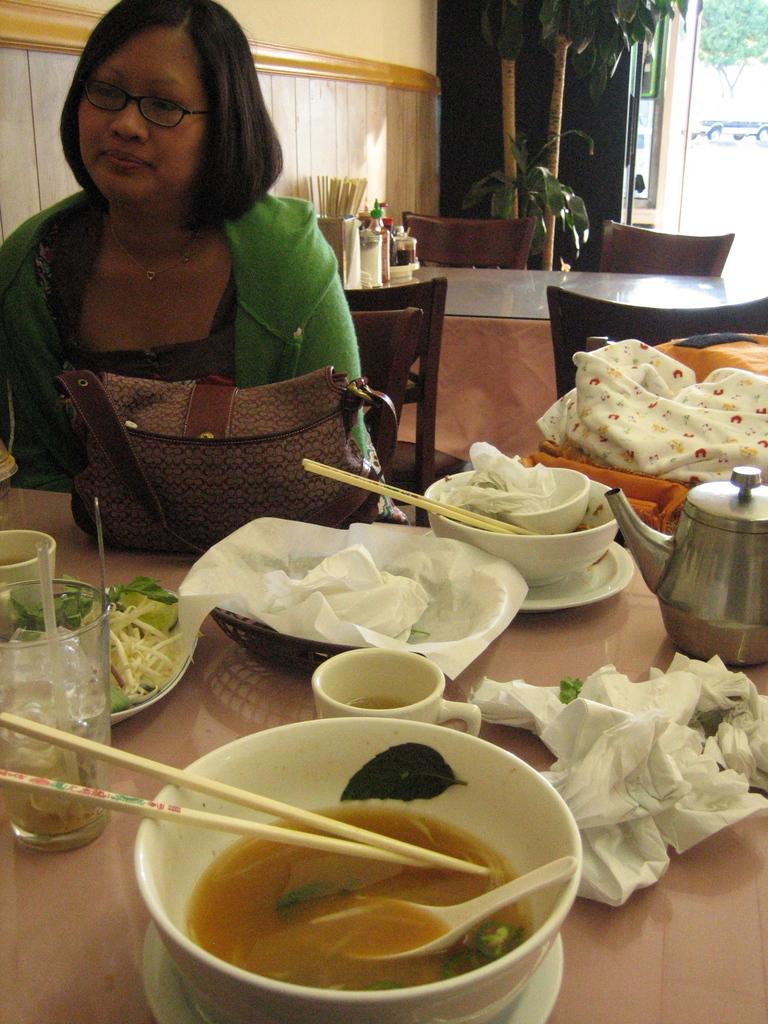What is the person in the image doing? The person is sitting on a chair in the image. Where is the person located in relation to the table? The person is around a table in the image. What can be found on the table in the image? There are food items on the table in the image. What is visible in the background of the image? There is a wall in the background of the image. How many scarecrows are present in the image? There are no scarecrows present in the image. What type of frogs can be seen hopping on the table in the image? There are no frogs present in the image, and therefore no such activity can be observed. 